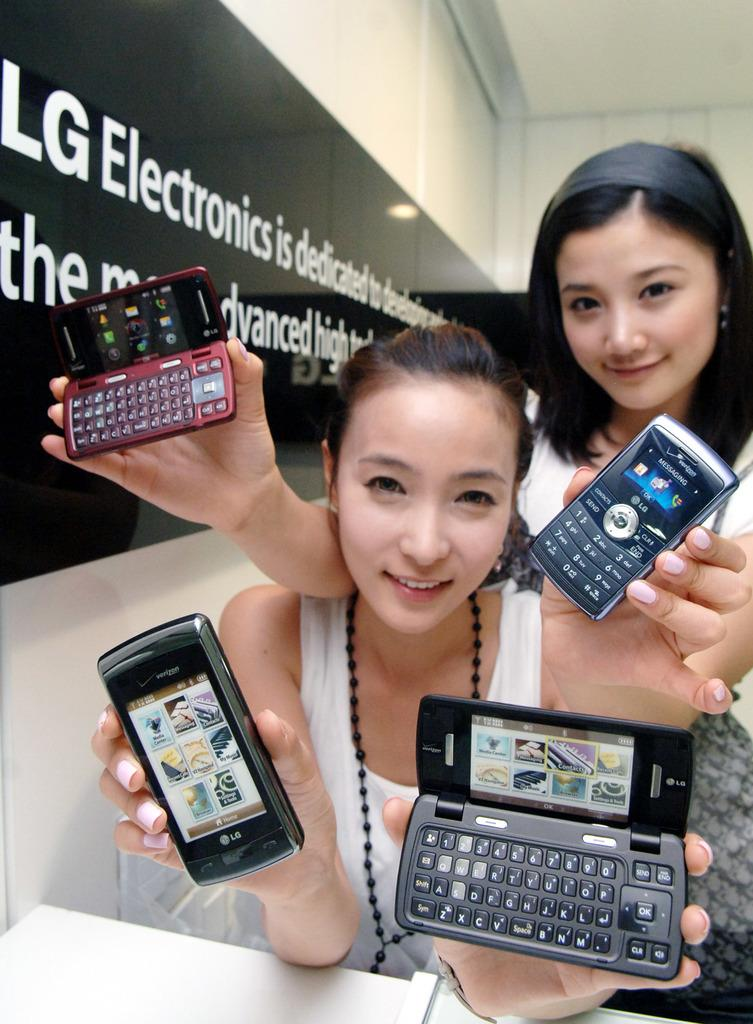How many women are present in the image? There are two women in the image. What are the women holding in their hands? Each woman is holding a mobile in her hand. What can be seen in the background of the image? There is a wall and a banner in the background of the image. What type of cattle can be seen in the image? There are no cattle present in the image. What agreement did the women reach in the image? There is no indication of an agreement or discussion between the women in the image. 